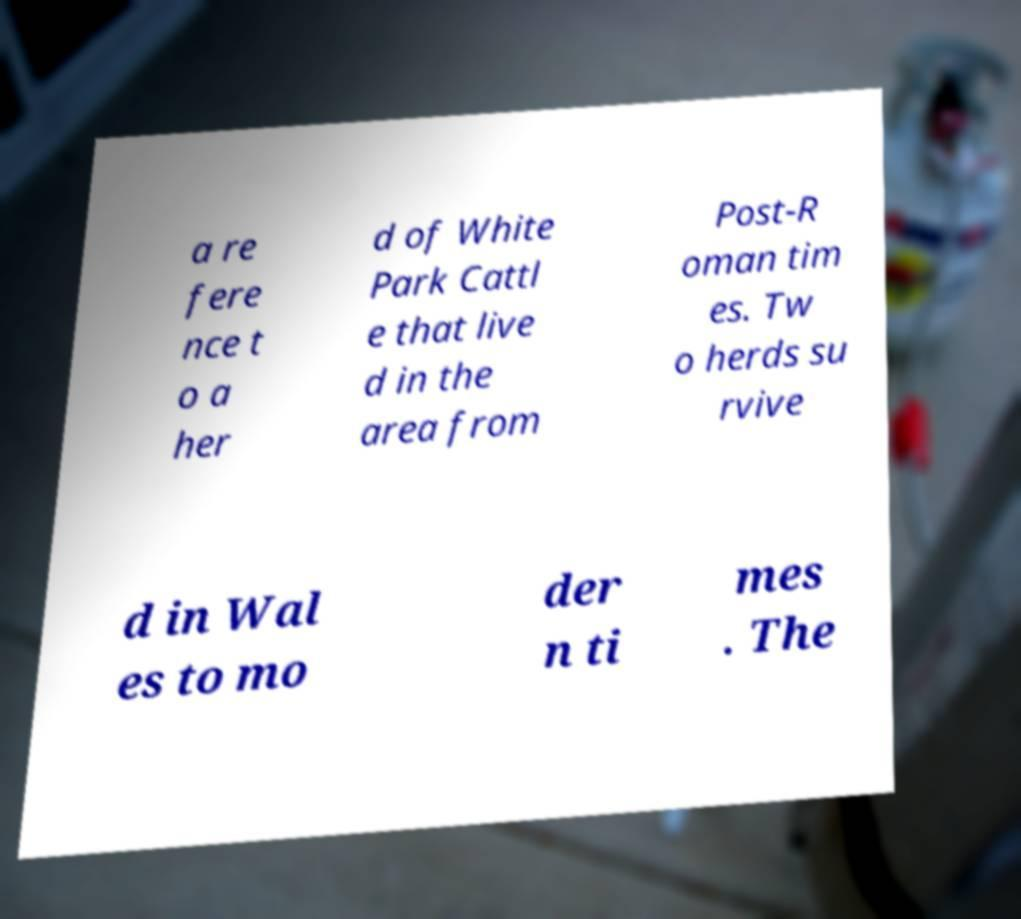Could you assist in decoding the text presented in this image and type it out clearly? a re fere nce t o a her d of White Park Cattl e that live d in the area from Post-R oman tim es. Tw o herds su rvive d in Wal es to mo der n ti mes . The 